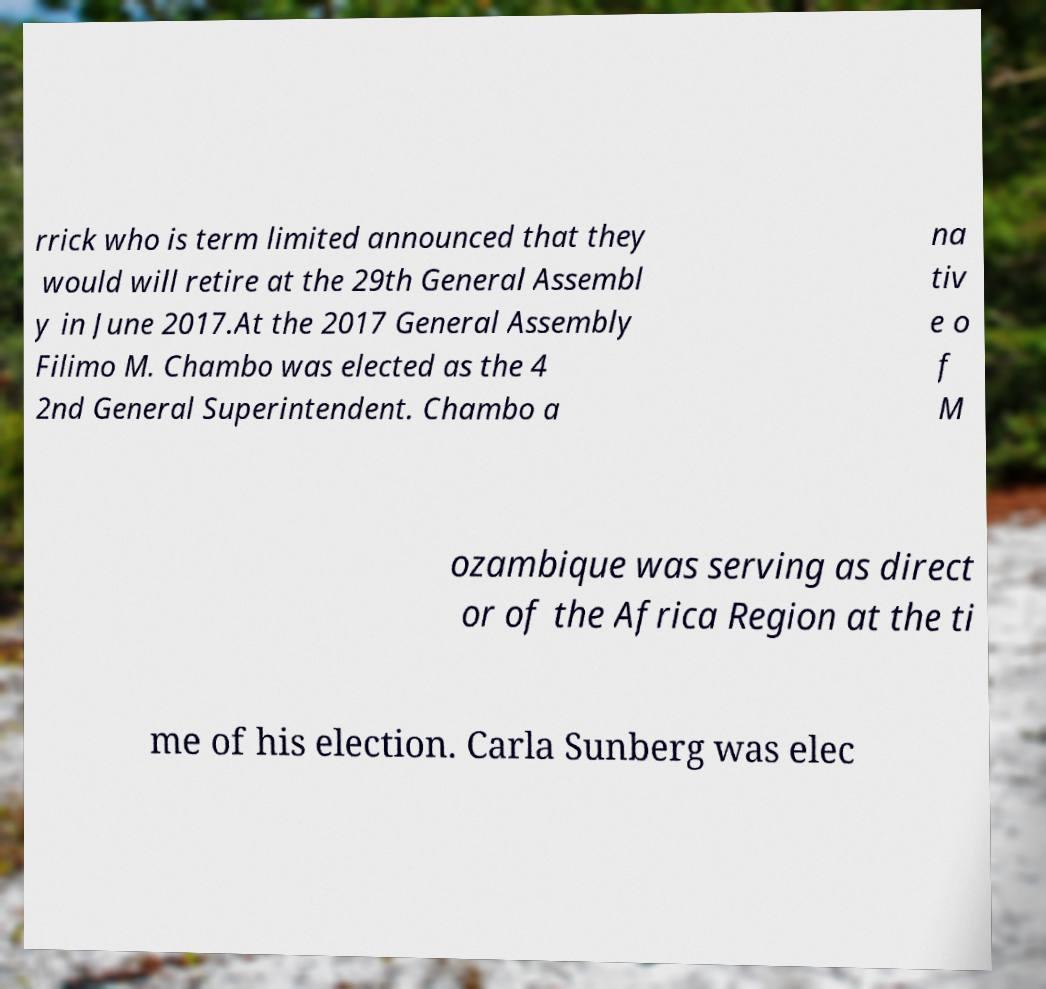Could you assist in decoding the text presented in this image and type it out clearly? rrick who is term limited announced that they would will retire at the 29th General Assembl y in June 2017.At the 2017 General Assembly Filimo M. Chambo was elected as the 4 2nd General Superintendent. Chambo a na tiv e o f M ozambique was serving as direct or of the Africa Region at the ti me of his election. Carla Sunberg was elec 